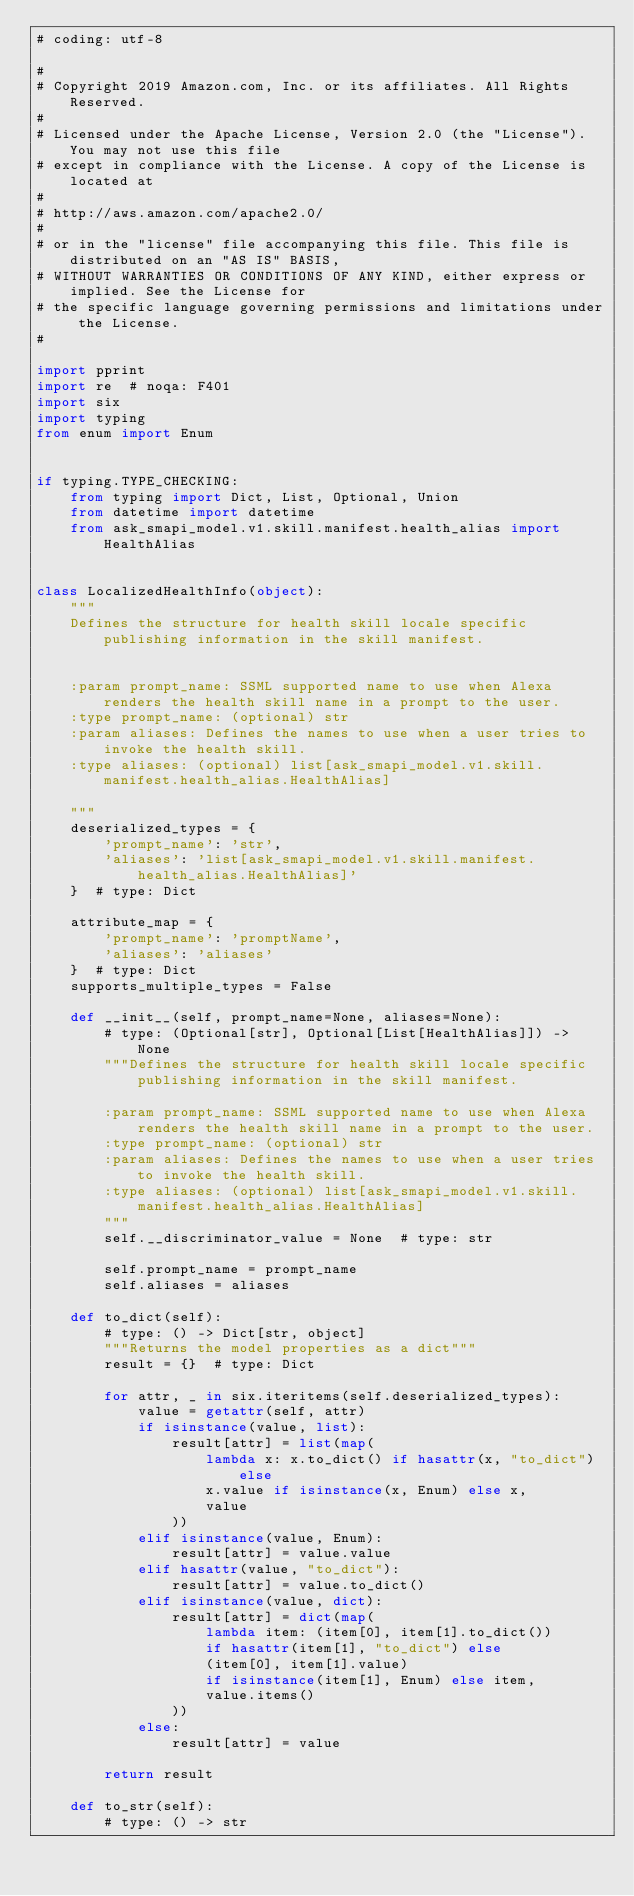<code> <loc_0><loc_0><loc_500><loc_500><_Python_># coding: utf-8

#
# Copyright 2019 Amazon.com, Inc. or its affiliates. All Rights Reserved.
#
# Licensed under the Apache License, Version 2.0 (the "License"). You may not use this file
# except in compliance with the License. A copy of the License is located at
#
# http://aws.amazon.com/apache2.0/
#
# or in the "license" file accompanying this file. This file is distributed on an "AS IS" BASIS,
# WITHOUT WARRANTIES OR CONDITIONS OF ANY KIND, either express or implied. See the License for
# the specific language governing permissions and limitations under the License.
#

import pprint
import re  # noqa: F401
import six
import typing
from enum import Enum


if typing.TYPE_CHECKING:
    from typing import Dict, List, Optional, Union
    from datetime import datetime
    from ask_smapi_model.v1.skill.manifest.health_alias import HealthAlias


class LocalizedHealthInfo(object):
    """
    Defines the structure for health skill locale specific publishing information in the skill manifest.


    :param prompt_name: SSML supported name to use when Alexa renders the health skill name in a prompt to the user.
    :type prompt_name: (optional) str
    :param aliases: Defines the names to use when a user tries to invoke the health skill.
    :type aliases: (optional) list[ask_smapi_model.v1.skill.manifest.health_alias.HealthAlias]

    """
    deserialized_types = {
        'prompt_name': 'str',
        'aliases': 'list[ask_smapi_model.v1.skill.manifest.health_alias.HealthAlias]'
    }  # type: Dict

    attribute_map = {
        'prompt_name': 'promptName',
        'aliases': 'aliases'
    }  # type: Dict
    supports_multiple_types = False

    def __init__(self, prompt_name=None, aliases=None):
        # type: (Optional[str], Optional[List[HealthAlias]]) -> None
        """Defines the structure for health skill locale specific publishing information in the skill manifest.

        :param prompt_name: SSML supported name to use when Alexa renders the health skill name in a prompt to the user.
        :type prompt_name: (optional) str
        :param aliases: Defines the names to use when a user tries to invoke the health skill.
        :type aliases: (optional) list[ask_smapi_model.v1.skill.manifest.health_alias.HealthAlias]
        """
        self.__discriminator_value = None  # type: str

        self.prompt_name = prompt_name
        self.aliases = aliases

    def to_dict(self):
        # type: () -> Dict[str, object]
        """Returns the model properties as a dict"""
        result = {}  # type: Dict

        for attr, _ in six.iteritems(self.deserialized_types):
            value = getattr(self, attr)
            if isinstance(value, list):
                result[attr] = list(map(
                    lambda x: x.to_dict() if hasattr(x, "to_dict") else
                    x.value if isinstance(x, Enum) else x,
                    value
                ))
            elif isinstance(value, Enum):
                result[attr] = value.value
            elif hasattr(value, "to_dict"):
                result[attr] = value.to_dict()
            elif isinstance(value, dict):
                result[attr] = dict(map(
                    lambda item: (item[0], item[1].to_dict())
                    if hasattr(item[1], "to_dict") else
                    (item[0], item[1].value)
                    if isinstance(item[1], Enum) else item,
                    value.items()
                ))
            else:
                result[attr] = value

        return result

    def to_str(self):
        # type: () -> str</code> 